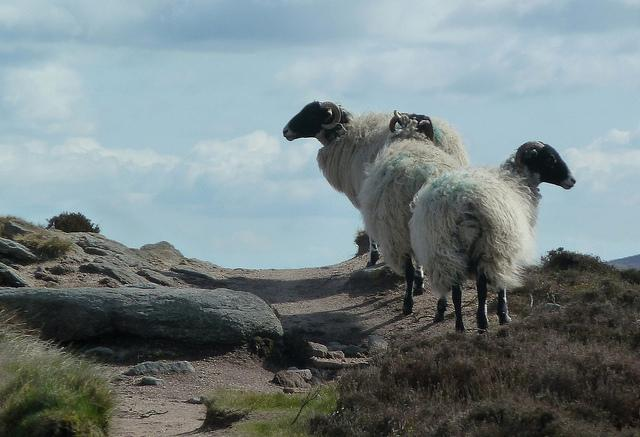What is a process that is related to these animals? shearing 